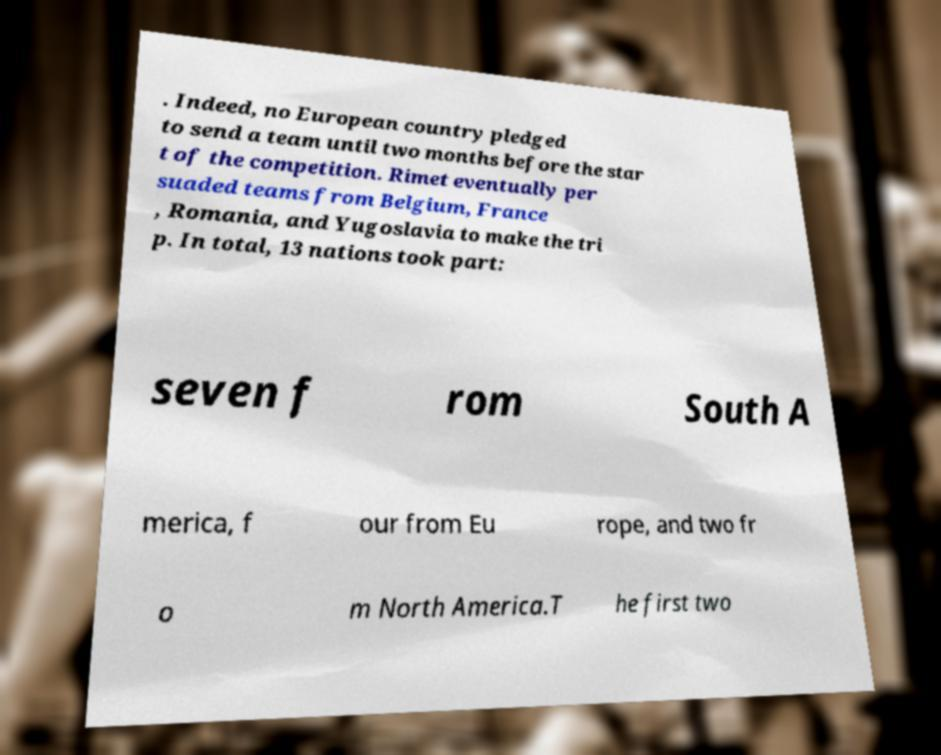Can you read and provide the text displayed in the image?This photo seems to have some interesting text. Can you extract and type it out for me? . Indeed, no European country pledged to send a team until two months before the star t of the competition. Rimet eventually per suaded teams from Belgium, France , Romania, and Yugoslavia to make the tri p. In total, 13 nations took part: seven f rom South A merica, f our from Eu rope, and two fr o m North America.T he first two 